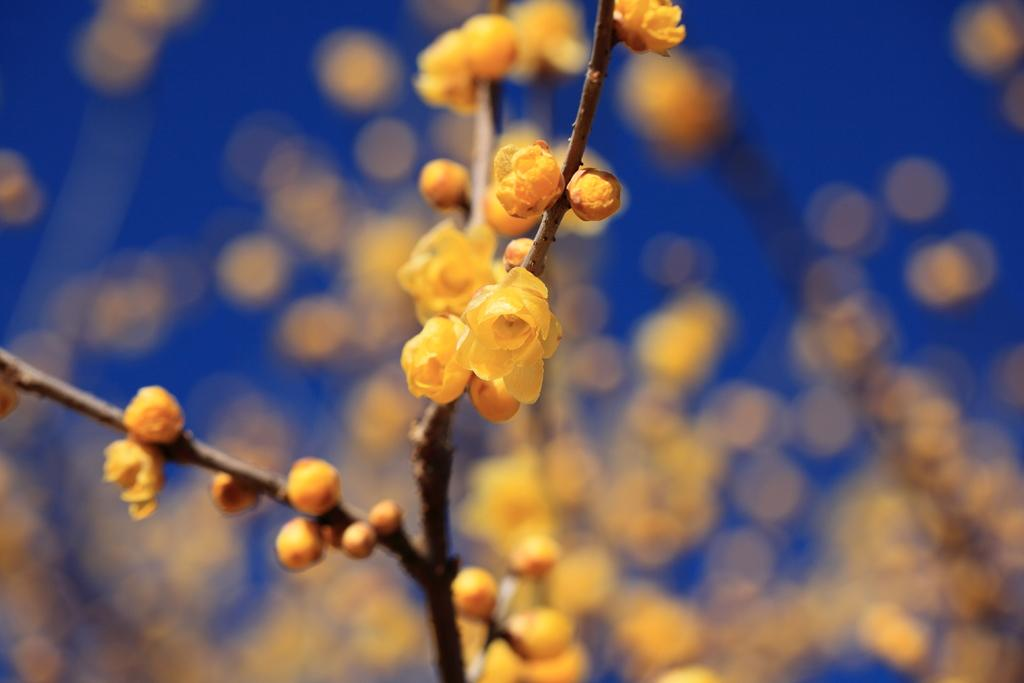What type of plants can be seen in the image? There are flowers in the image. What color are the flowers? The flowers are yellow. What color is the background of the image? The background of the image is blue. What grade does the disgusting snow receive in the image? There is no mention of snow or any grading system in the image, so this question cannot be answered. 